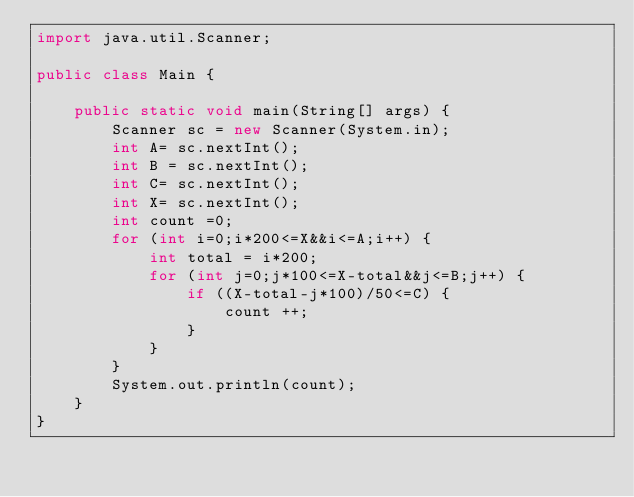Convert code to text. <code><loc_0><loc_0><loc_500><loc_500><_Java_>import java.util.Scanner;

public class Main {

	public static void main(String[] args) {
		Scanner sc = new Scanner(System.in);
		int A= sc.nextInt();
		int B = sc.nextInt();
		int C= sc.nextInt();
		int X= sc.nextInt();
		int count =0;
		for (int i=0;i*200<=X&&i<=A;i++) {
			int total = i*200;
			for (int j=0;j*100<=X-total&&j<=B;j++) {
				if ((X-total-j*100)/50<=C) {
					count ++;
				}
			}
		}
		System.out.println(count);
	}
}</code> 